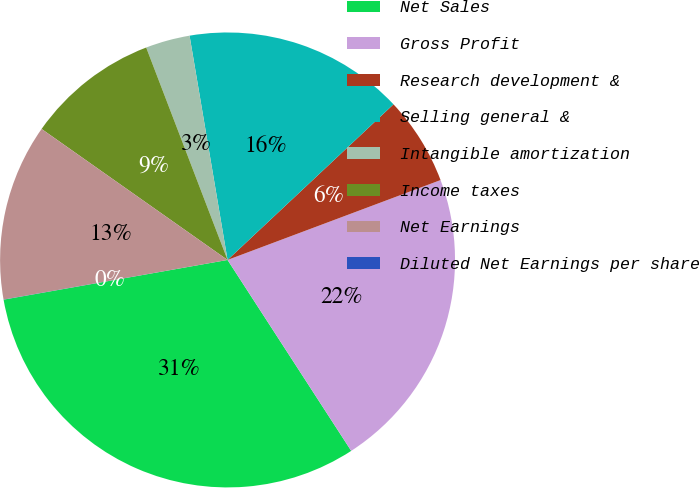Convert chart. <chart><loc_0><loc_0><loc_500><loc_500><pie_chart><fcel>Net Sales<fcel>Gross Profit<fcel>Research development &<fcel>Selling general &<fcel>Intangible amortization<fcel>Income taxes<fcel>Net Earnings<fcel>Diluted Net Earnings per share<nl><fcel>31.35%<fcel>21.56%<fcel>6.28%<fcel>15.68%<fcel>3.15%<fcel>9.41%<fcel>12.55%<fcel>0.01%<nl></chart> 